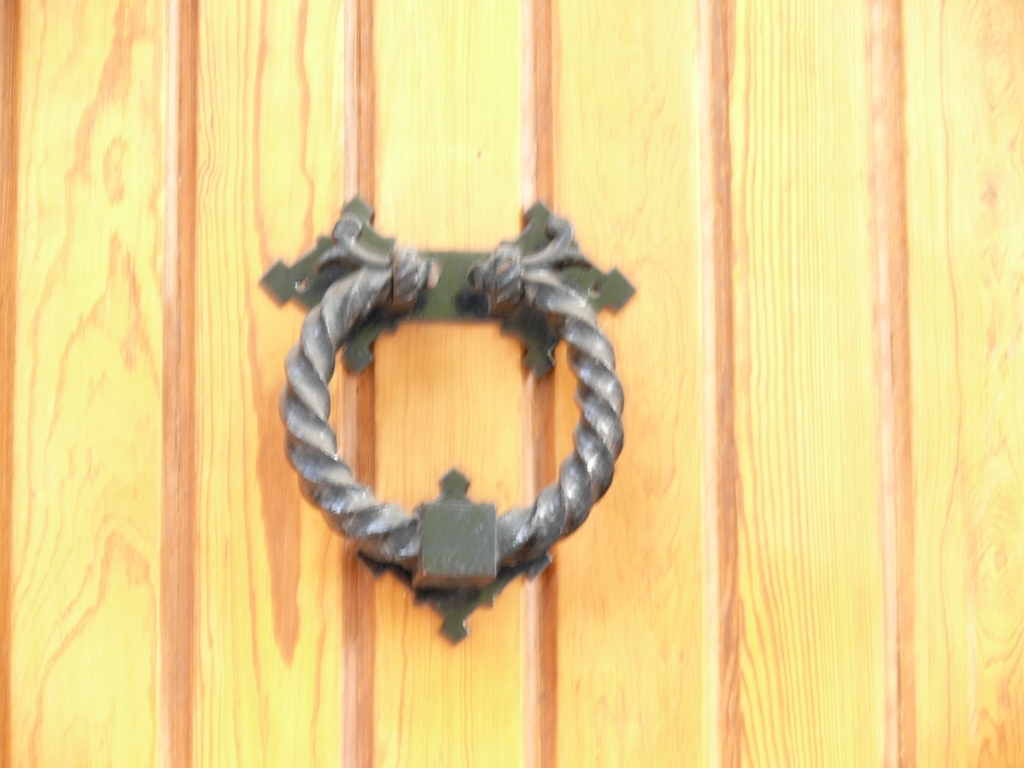Are there any quality issues with this image? Yes, the image appears to be out of focus, which affects the sharpness and clarity of the subject, a door knocker. Additionally, the lighting seems flat which reduces the contrast and depth in the image. 